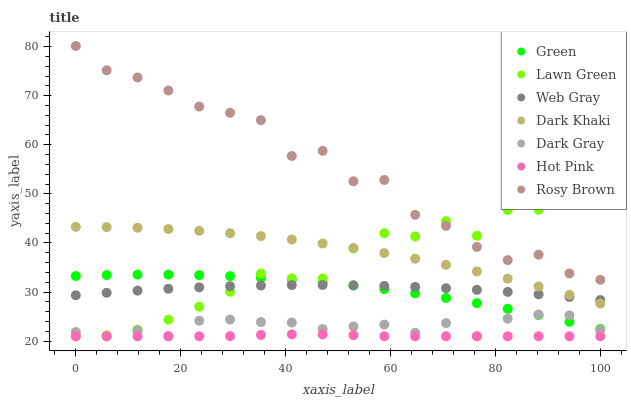Does Hot Pink have the minimum area under the curve?
Answer yes or no. Yes. Does Rosy Brown have the maximum area under the curve?
Answer yes or no. Yes. Does Web Gray have the minimum area under the curve?
Answer yes or no. No. Does Web Gray have the maximum area under the curve?
Answer yes or no. No. Is Hot Pink the smoothest?
Answer yes or no. Yes. Is Rosy Brown the roughest?
Answer yes or no. Yes. Is Web Gray the smoothest?
Answer yes or no. No. Is Web Gray the roughest?
Answer yes or no. No. Does Lawn Green have the lowest value?
Answer yes or no. Yes. Does Web Gray have the lowest value?
Answer yes or no. No. Does Rosy Brown have the highest value?
Answer yes or no. Yes. Does Web Gray have the highest value?
Answer yes or no. No. Is Hot Pink less than Web Gray?
Answer yes or no. Yes. Is Web Gray greater than Dark Gray?
Answer yes or no. Yes. Does Hot Pink intersect Lawn Green?
Answer yes or no. Yes. Is Hot Pink less than Lawn Green?
Answer yes or no. No. Is Hot Pink greater than Lawn Green?
Answer yes or no. No. Does Hot Pink intersect Web Gray?
Answer yes or no. No. 